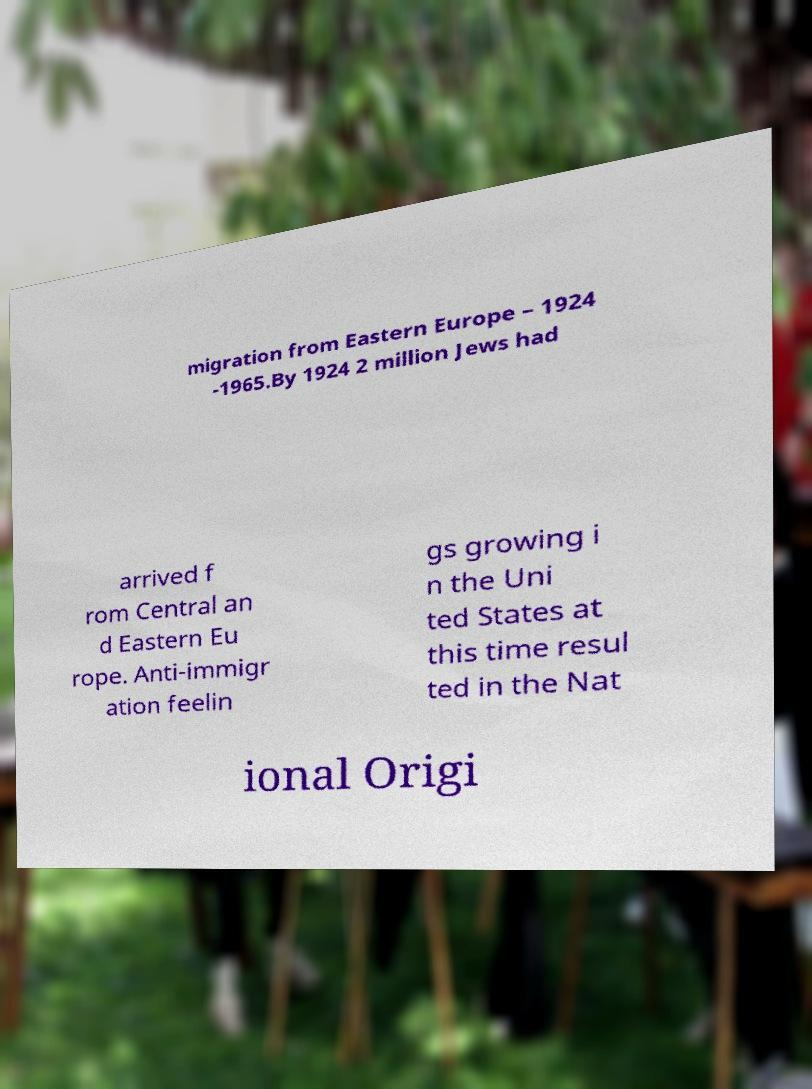For documentation purposes, I need the text within this image transcribed. Could you provide that? migration from Eastern Europe – 1924 -1965.By 1924 2 million Jews had arrived f rom Central an d Eastern Eu rope. Anti-immigr ation feelin gs growing i n the Uni ted States at this time resul ted in the Nat ional Origi 